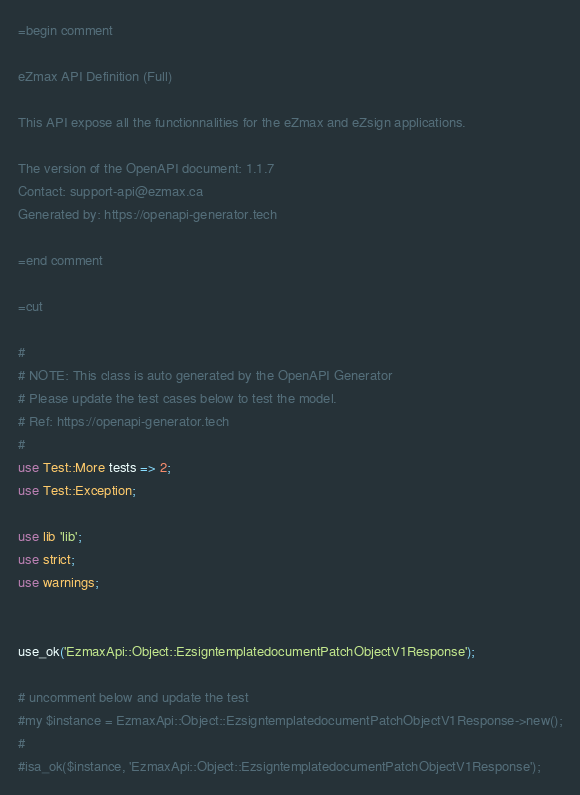<code> <loc_0><loc_0><loc_500><loc_500><_Perl_>=begin comment

eZmax API Definition (Full)

This API expose all the functionnalities for the eZmax and eZsign applications.

The version of the OpenAPI document: 1.1.7
Contact: support-api@ezmax.ca
Generated by: https://openapi-generator.tech

=end comment

=cut

#
# NOTE: This class is auto generated by the OpenAPI Generator
# Please update the test cases below to test the model.
# Ref: https://openapi-generator.tech
#
use Test::More tests => 2;
use Test::Exception;

use lib 'lib';
use strict;
use warnings;


use_ok('EzmaxApi::Object::EzsigntemplatedocumentPatchObjectV1Response');

# uncomment below and update the test
#my $instance = EzmaxApi::Object::EzsigntemplatedocumentPatchObjectV1Response->new();
#
#isa_ok($instance, 'EzmaxApi::Object::EzsigntemplatedocumentPatchObjectV1Response');

</code> 